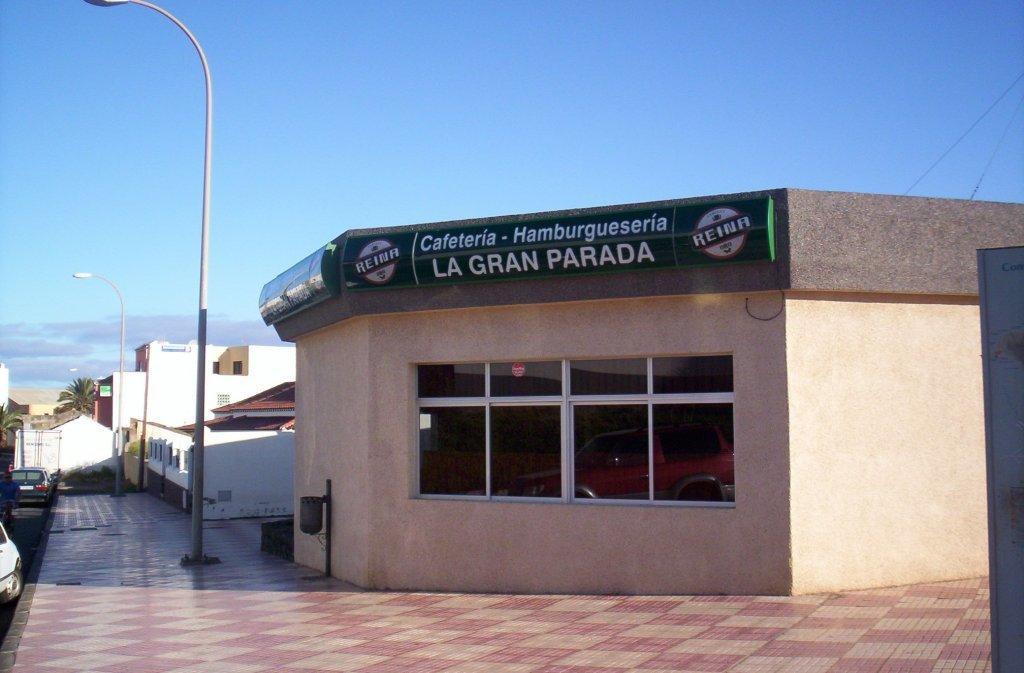In one or two sentences, can you explain what this image depicts? In the picture we can see a path with tiles and on it we can see the poles with lights and besides it, we can see houses and to the house we can see glass windows and written on top of it as cafeteria hamburgerseria and in the background we can see houses, trees and sky with clouds. 